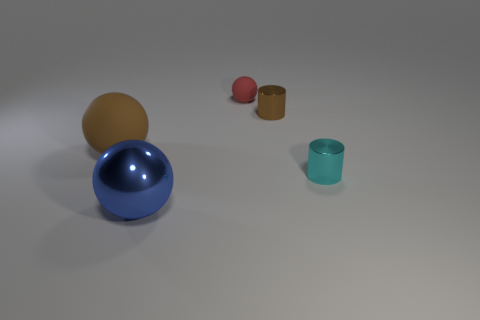Add 5 matte balls. How many objects exist? 10 Subtract all spheres. How many objects are left? 2 Subtract all tiny brown cylinders. Subtract all brown objects. How many objects are left? 2 Add 2 small matte things. How many small matte things are left? 3 Add 2 large brown metallic spheres. How many large brown metallic spheres exist? 2 Subtract 0 yellow blocks. How many objects are left? 5 